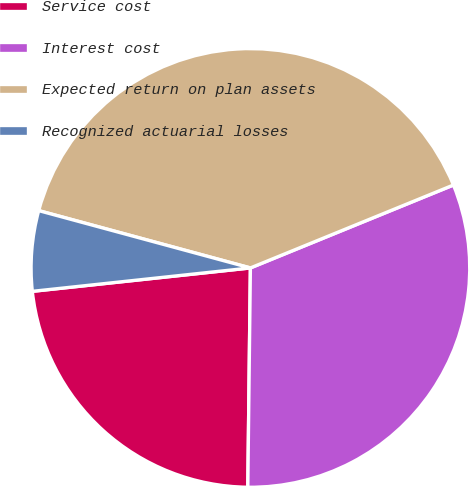Convert chart. <chart><loc_0><loc_0><loc_500><loc_500><pie_chart><fcel>Service cost<fcel>Interest cost<fcel>Expected return on plan assets<fcel>Recognized actuarial losses<nl><fcel>23.11%<fcel>31.36%<fcel>39.62%<fcel>5.91%<nl></chart> 